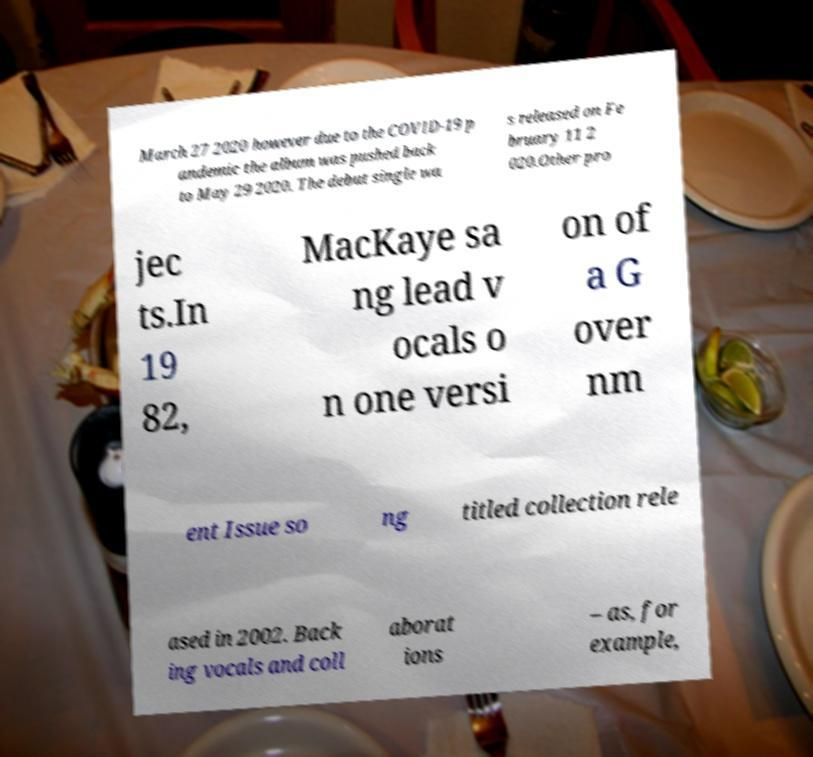Can you accurately transcribe the text from the provided image for me? March 27 2020 however due to the COVID-19 p andemic the album was pushed back to May 29 2020. The debut single wa s released on Fe bruary 11 2 020.Other pro jec ts.In 19 82, MacKaye sa ng lead v ocals o n one versi on of a G over nm ent Issue so ng titled collection rele ased in 2002. Back ing vocals and coll aborat ions – as, for example, 